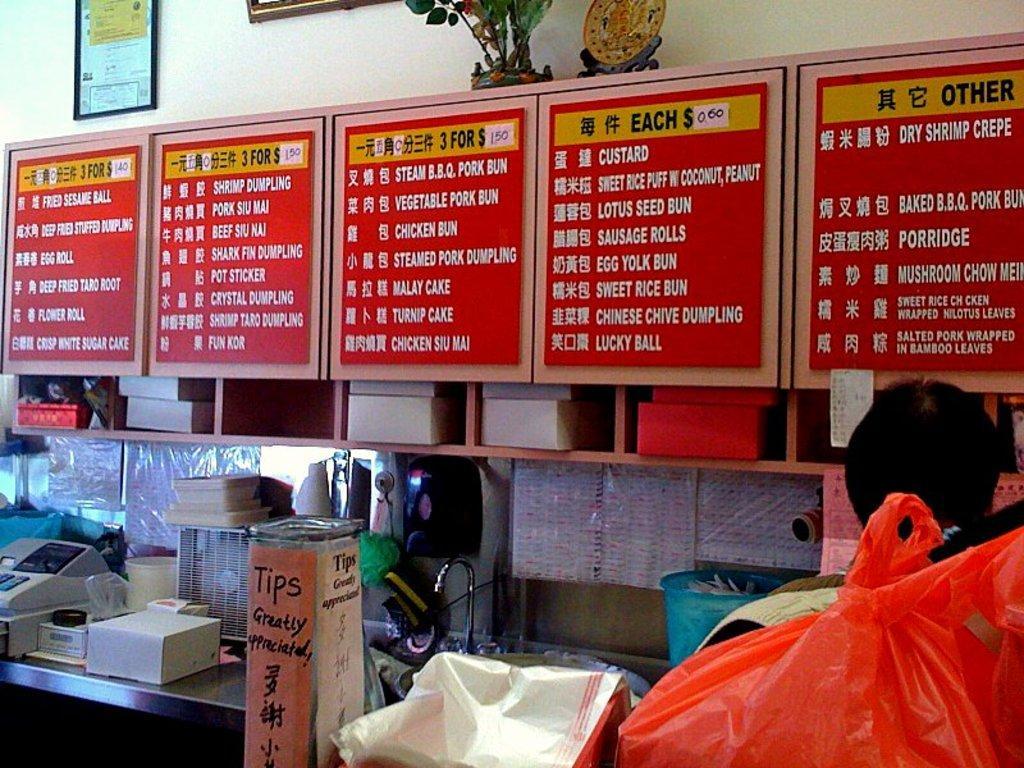Can you describe this image briefly? In this image, we can see a table contains some objects. There are boards in front of the wall. There is a There are boxes in the middle of the image. There is a shield at the top of the image. There is a photo frame in the top left of the image. 